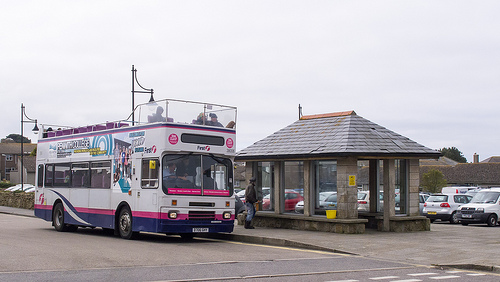Describe the architecture and style of the bus shelter in the image. The bus shelter in the image features a sturdy, rustic design that blends traditional elements with modern functionality. It has a slate roof resembling those often found in countryside or coastal settings, indicating a design choice made to withstand local weather conditions. The shelter is enclosed with large glass panels, offering visibility and protection from the elements while waiting for the bus. Stone or concrete blocks form the base, giving it a robust structure and a touch of natural aesthetic. Why do you think the bus has open-top seating? The open-top seating on the bus is likely designed for sightseeing purposes. It allows passengers to enjoy uninterrupted views of the surroundings and experience fresh air during their journey. This type of bus is commonly used in tours of scenic areas, giving tourists a panoramic perspective that's both engaging and enjoyable. 